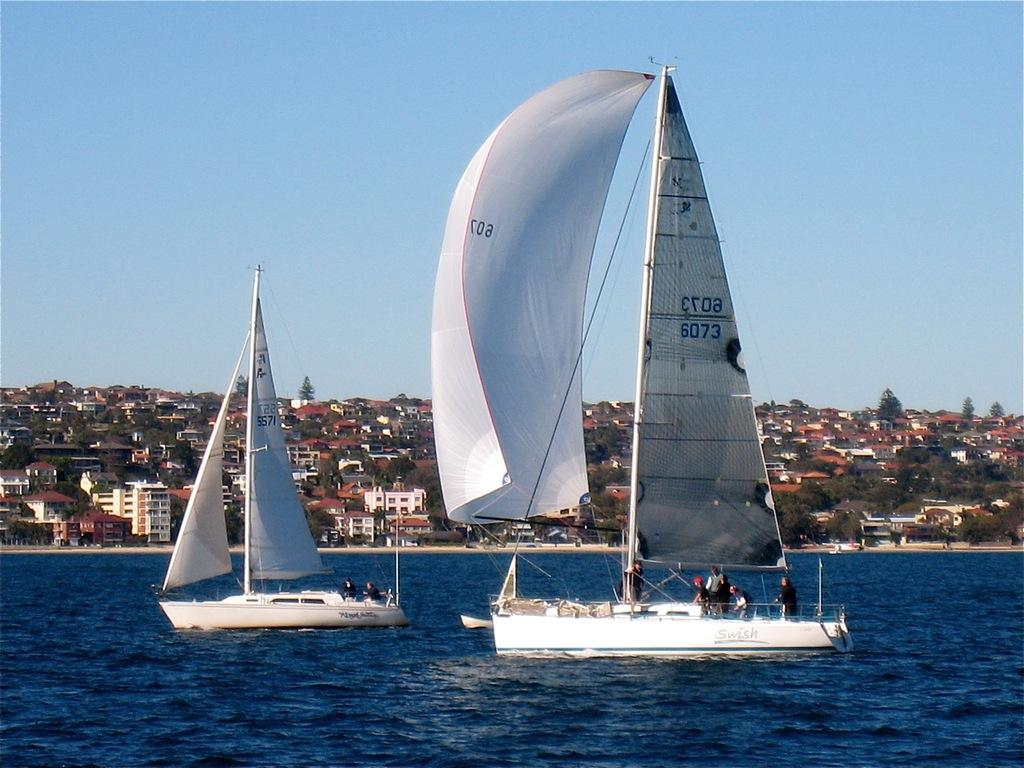What are the people in the image doing? There are people on the boats in the image. What can be seen in the background of the image? There are buildings and trees in the background of the image. What is visible at the top of the image? The sky is visible at the top of the image. What is present at the bottom of the image? Water is present at the bottom of the image. How many fingers does the competition have in the image? There is no competition present in the image, and therefore no fingers to count. 